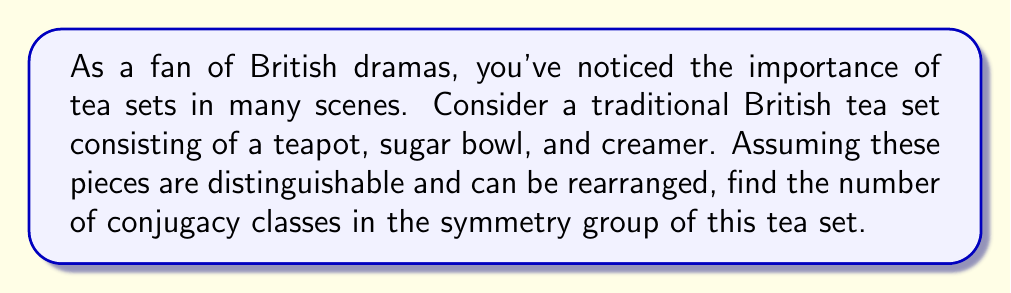Can you solve this math problem? Let's approach this step-by-step:

1) First, we need to understand what the symmetry group of this tea set is. It's the group of all possible permutations of the three pieces. This is isomorphic to the symmetric group $S_3$.

2) The order of $S_3$ is $3! = 6$. The elements are:
   $e$ (identity)
   $(1\,2)$, $(1\,3)$, $(2\,3)$ (2-cycles or transpositions)
   $(1\,2\,3)$, $(1\,3\,2)$ (3-cycles)

3) To find the number of conjugacy classes, we need to group these elements based on their cycle structure:
   - $e$ is in its own conjugacy class
   - All 2-cycles are conjugate to each other
   - All 3-cycles are conjugate to each other

4) The number of conjugacy classes is equal to the number of these groups.

5) Alternatively, we can use the formula for the number of conjugacy classes in $S_n$:
   The number of conjugacy classes in $S_n$ is equal to the number of integer partitions of $n$.

6) The integer partitions of 3 are:
   3
   2 + 1
   1 + 1 + 1

Therefore, there are 3 conjugacy classes in $S_3$, which is the symmetry group of our tea set.
Answer: 3 conjugacy classes 